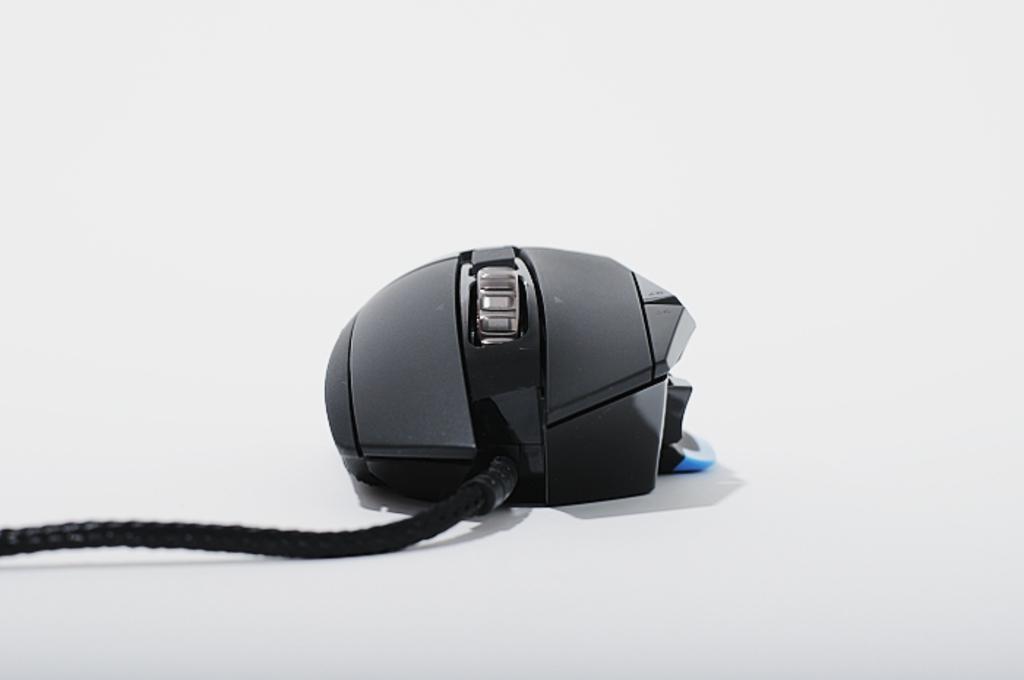Please provide a concise description of this image. This picture contains a computer mouse. It is in black color. It has a black wire. In the background, it is white in color. 